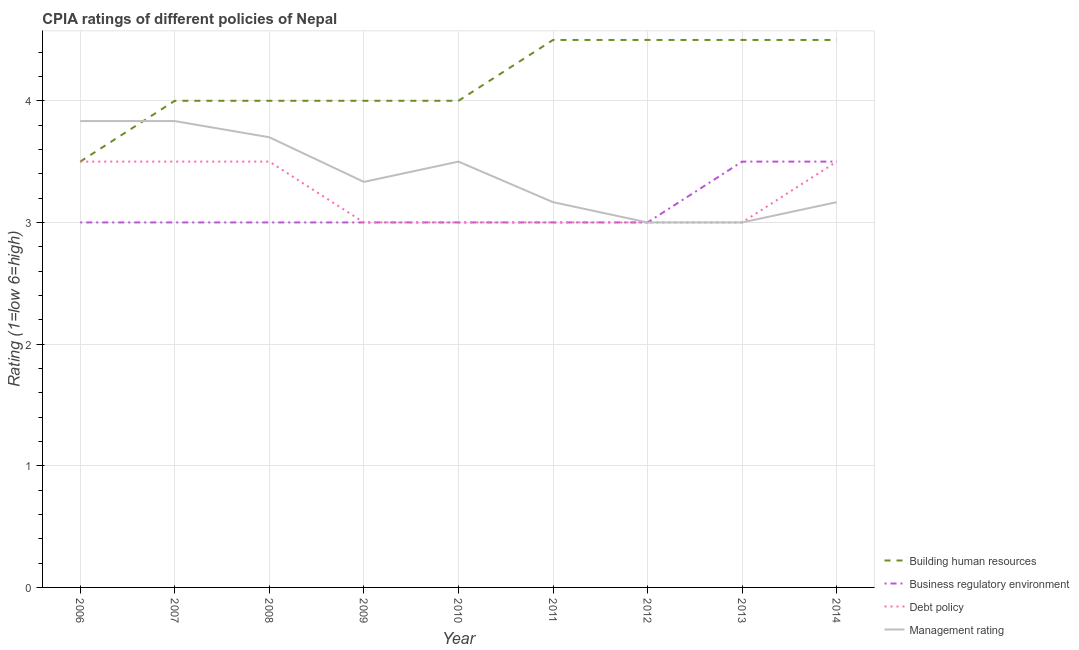How many different coloured lines are there?
Make the answer very short. 4. Across all years, what is the maximum cpia rating of business regulatory environment?
Keep it short and to the point. 3.5. In which year was the cpia rating of management maximum?
Your answer should be compact. 2006. In which year was the cpia rating of business regulatory environment minimum?
Give a very brief answer. 2006. What is the difference between the cpia rating of management in 2008 and that in 2012?
Your answer should be compact. 0.7. What is the difference between the cpia rating of debt policy in 2008 and the cpia rating of business regulatory environment in 2010?
Offer a very short reply. 0.5. What is the average cpia rating of debt policy per year?
Provide a short and direct response. 3.22. In the year 2014, what is the difference between the cpia rating of building human resources and cpia rating of business regulatory environment?
Provide a succinct answer. 1. In how many years, is the cpia rating of building human resources greater than 0.4?
Make the answer very short. 9. Is the cpia rating of management in 2009 less than that in 2013?
Your answer should be compact. No. Is the difference between the cpia rating of building human resources in 2012 and 2014 greater than the difference between the cpia rating of debt policy in 2012 and 2014?
Give a very brief answer. Yes. What is the difference between the highest and the lowest cpia rating of debt policy?
Your answer should be compact. 0.5. Is it the case that in every year, the sum of the cpia rating of business regulatory environment and cpia rating of debt policy is greater than the sum of cpia rating of management and cpia rating of building human resources?
Make the answer very short. No. Is it the case that in every year, the sum of the cpia rating of building human resources and cpia rating of business regulatory environment is greater than the cpia rating of debt policy?
Provide a short and direct response. Yes. Does the cpia rating of debt policy monotonically increase over the years?
Provide a short and direct response. No. Is the cpia rating of building human resources strictly less than the cpia rating of management over the years?
Offer a terse response. No. How many lines are there?
Provide a short and direct response. 4. What is the difference between two consecutive major ticks on the Y-axis?
Provide a short and direct response. 1. What is the title of the graph?
Your answer should be compact. CPIA ratings of different policies of Nepal. What is the label or title of the X-axis?
Ensure brevity in your answer.  Year. What is the label or title of the Y-axis?
Make the answer very short. Rating (1=low 6=high). What is the Rating (1=low 6=high) of Building human resources in 2006?
Your answer should be compact. 3.5. What is the Rating (1=low 6=high) in Business regulatory environment in 2006?
Your response must be concise. 3. What is the Rating (1=low 6=high) in Management rating in 2006?
Your response must be concise. 3.83. What is the Rating (1=low 6=high) in Business regulatory environment in 2007?
Your answer should be compact. 3. What is the Rating (1=low 6=high) in Debt policy in 2007?
Keep it short and to the point. 3.5. What is the Rating (1=low 6=high) of Management rating in 2007?
Ensure brevity in your answer.  3.83. What is the Rating (1=low 6=high) in Building human resources in 2008?
Give a very brief answer. 4. What is the Rating (1=low 6=high) in Business regulatory environment in 2008?
Ensure brevity in your answer.  3. What is the Rating (1=low 6=high) in Management rating in 2008?
Offer a terse response. 3.7. What is the Rating (1=low 6=high) of Building human resources in 2009?
Ensure brevity in your answer.  4. What is the Rating (1=low 6=high) of Business regulatory environment in 2009?
Provide a succinct answer. 3. What is the Rating (1=low 6=high) of Debt policy in 2009?
Offer a very short reply. 3. What is the Rating (1=low 6=high) of Management rating in 2009?
Provide a short and direct response. 3.33. What is the Rating (1=low 6=high) of Building human resources in 2010?
Provide a short and direct response. 4. What is the Rating (1=low 6=high) of Business regulatory environment in 2010?
Your answer should be very brief. 3. What is the Rating (1=low 6=high) of Debt policy in 2010?
Give a very brief answer. 3. What is the Rating (1=low 6=high) of Debt policy in 2011?
Offer a very short reply. 3. What is the Rating (1=low 6=high) of Management rating in 2011?
Your response must be concise. 3.17. What is the Rating (1=low 6=high) in Building human resources in 2013?
Your response must be concise. 4.5. What is the Rating (1=low 6=high) in Management rating in 2014?
Provide a short and direct response. 3.17. Across all years, what is the maximum Rating (1=low 6=high) of Building human resources?
Your answer should be very brief. 4.5. Across all years, what is the maximum Rating (1=low 6=high) of Management rating?
Your response must be concise. 3.83. Across all years, what is the minimum Rating (1=low 6=high) in Business regulatory environment?
Keep it short and to the point. 3. Across all years, what is the minimum Rating (1=low 6=high) of Debt policy?
Offer a terse response. 3. What is the total Rating (1=low 6=high) of Building human resources in the graph?
Provide a succinct answer. 37.5. What is the total Rating (1=low 6=high) of Business regulatory environment in the graph?
Your answer should be very brief. 28. What is the total Rating (1=low 6=high) of Debt policy in the graph?
Provide a succinct answer. 29. What is the total Rating (1=low 6=high) of Management rating in the graph?
Your answer should be very brief. 30.53. What is the difference between the Rating (1=low 6=high) of Business regulatory environment in 2006 and that in 2007?
Your response must be concise. 0. What is the difference between the Rating (1=low 6=high) of Debt policy in 2006 and that in 2007?
Offer a terse response. 0. What is the difference between the Rating (1=low 6=high) in Management rating in 2006 and that in 2007?
Make the answer very short. 0. What is the difference between the Rating (1=low 6=high) of Building human resources in 2006 and that in 2008?
Provide a succinct answer. -0.5. What is the difference between the Rating (1=low 6=high) in Management rating in 2006 and that in 2008?
Your answer should be compact. 0.13. What is the difference between the Rating (1=low 6=high) in Building human resources in 2006 and that in 2009?
Keep it short and to the point. -0.5. What is the difference between the Rating (1=low 6=high) of Debt policy in 2006 and that in 2009?
Make the answer very short. 0.5. What is the difference between the Rating (1=low 6=high) of Management rating in 2006 and that in 2009?
Keep it short and to the point. 0.5. What is the difference between the Rating (1=low 6=high) of Building human resources in 2006 and that in 2010?
Keep it short and to the point. -0.5. What is the difference between the Rating (1=low 6=high) of Management rating in 2006 and that in 2010?
Offer a very short reply. 0.33. What is the difference between the Rating (1=low 6=high) of Business regulatory environment in 2006 and that in 2011?
Provide a succinct answer. 0. What is the difference between the Rating (1=low 6=high) of Debt policy in 2006 and that in 2011?
Ensure brevity in your answer.  0.5. What is the difference between the Rating (1=low 6=high) in Management rating in 2006 and that in 2011?
Ensure brevity in your answer.  0.67. What is the difference between the Rating (1=low 6=high) in Business regulatory environment in 2006 and that in 2012?
Offer a terse response. 0. What is the difference between the Rating (1=low 6=high) of Debt policy in 2006 and that in 2012?
Your response must be concise. 0.5. What is the difference between the Rating (1=low 6=high) in Management rating in 2006 and that in 2012?
Ensure brevity in your answer.  0.83. What is the difference between the Rating (1=low 6=high) in Building human resources in 2006 and that in 2013?
Ensure brevity in your answer.  -1. What is the difference between the Rating (1=low 6=high) of Business regulatory environment in 2006 and that in 2013?
Keep it short and to the point. -0.5. What is the difference between the Rating (1=low 6=high) in Debt policy in 2006 and that in 2013?
Offer a terse response. 0.5. What is the difference between the Rating (1=low 6=high) in Management rating in 2006 and that in 2013?
Your answer should be compact. 0.83. What is the difference between the Rating (1=low 6=high) in Business regulatory environment in 2006 and that in 2014?
Your response must be concise. -0.5. What is the difference between the Rating (1=low 6=high) in Management rating in 2006 and that in 2014?
Ensure brevity in your answer.  0.67. What is the difference between the Rating (1=low 6=high) in Management rating in 2007 and that in 2008?
Your answer should be very brief. 0.13. What is the difference between the Rating (1=low 6=high) in Building human resources in 2007 and that in 2009?
Give a very brief answer. 0. What is the difference between the Rating (1=low 6=high) in Debt policy in 2007 and that in 2009?
Offer a very short reply. 0.5. What is the difference between the Rating (1=low 6=high) of Management rating in 2007 and that in 2009?
Offer a terse response. 0.5. What is the difference between the Rating (1=low 6=high) in Business regulatory environment in 2007 and that in 2010?
Your answer should be compact. 0. What is the difference between the Rating (1=low 6=high) in Debt policy in 2007 and that in 2010?
Give a very brief answer. 0.5. What is the difference between the Rating (1=low 6=high) of Management rating in 2007 and that in 2010?
Offer a very short reply. 0.33. What is the difference between the Rating (1=low 6=high) of Building human resources in 2007 and that in 2011?
Offer a terse response. -0.5. What is the difference between the Rating (1=low 6=high) in Business regulatory environment in 2007 and that in 2011?
Keep it short and to the point. 0. What is the difference between the Rating (1=low 6=high) of Business regulatory environment in 2007 and that in 2012?
Make the answer very short. 0. What is the difference between the Rating (1=low 6=high) in Management rating in 2007 and that in 2012?
Ensure brevity in your answer.  0.83. What is the difference between the Rating (1=low 6=high) of Business regulatory environment in 2007 and that in 2013?
Your answer should be compact. -0.5. What is the difference between the Rating (1=low 6=high) in Building human resources in 2007 and that in 2014?
Provide a succinct answer. -0.5. What is the difference between the Rating (1=low 6=high) of Management rating in 2007 and that in 2014?
Offer a very short reply. 0.67. What is the difference between the Rating (1=low 6=high) of Management rating in 2008 and that in 2009?
Offer a terse response. 0.37. What is the difference between the Rating (1=low 6=high) of Building human resources in 2008 and that in 2010?
Your answer should be very brief. 0. What is the difference between the Rating (1=low 6=high) in Management rating in 2008 and that in 2010?
Your answer should be compact. 0.2. What is the difference between the Rating (1=low 6=high) in Building human resources in 2008 and that in 2011?
Keep it short and to the point. -0.5. What is the difference between the Rating (1=low 6=high) in Debt policy in 2008 and that in 2011?
Keep it short and to the point. 0.5. What is the difference between the Rating (1=low 6=high) of Management rating in 2008 and that in 2011?
Provide a succinct answer. 0.53. What is the difference between the Rating (1=low 6=high) in Business regulatory environment in 2008 and that in 2012?
Provide a short and direct response. 0. What is the difference between the Rating (1=low 6=high) of Management rating in 2008 and that in 2012?
Your answer should be compact. 0.7. What is the difference between the Rating (1=low 6=high) of Building human resources in 2008 and that in 2013?
Make the answer very short. -0.5. What is the difference between the Rating (1=low 6=high) of Management rating in 2008 and that in 2013?
Keep it short and to the point. 0.7. What is the difference between the Rating (1=low 6=high) in Debt policy in 2008 and that in 2014?
Your answer should be compact. 0. What is the difference between the Rating (1=low 6=high) of Management rating in 2008 and that in 2014?
Make the answer very short. 0.53. What is the difference between the Rating (1=low 6=high) of Building human resources in 2009 and that in 2010?
Make the answer very short. 0. What is the difference between the Rating (1=low 6=high) in Business regulatory environment in 2009 and that in 2010?
Your response must be concise. 0. What is the difference between the Rating (1=low 6=high) of Debt policy in 2009 and that in 2010?
Ensure brevity in your answer.  0. What is the difference between the Rating (1=low 6=high) of Management rating in 2009 and that in 2011?
Your response must be concise. 0.17. What is the difference between the Rating (1=low 6=high) in Building human resources in 2009 and that in 2012?
Ensure brevity in your answer.  -0.5. What is the difference between the Rating (1=low 6=high) in Management rating in 2009 and that in 2012?
Offer a very short reply. 0.33. What is the difference between the Rating (1=low 6=high) in Building human resources in 2009 and that in 2013?
Make the answer very short. -0.5. What is the difference between the Rating (1=low 6=high) in Business regulatory environment in 2009 and that in 2013?
Offer a very short reply. -0.5. What is the difference between the Rating (1=low 6=high) of Management rating in 2009 and that in 2013?
Ensure brevity in your answer.  0.33. What is the difference between the Rating (1=low 6=high) of Building human resources in 2009 and that in 2014?
Offer a terse response. -0.5. What is the difference between the Rating (1=low 6=high) in Business regulatory environment in 2009 and that in 2014?
Offer a terse response. -0.5. What is the difference between the Rating (1=low 6=high) of Debt policy in 2009 and that in 2014?
Provide a succinct answer. -0.5. What is the difference between the Rating (1=low 6=high) in Management rating in 2009 and that in 2014?
Offer a terse response. 0.17. What is the difference between the Rating (1=low 6=high) in Building human resources in 2010 and that in 2011?
Keep it short and to the point. -0.5. What is the difference between the Rating (1=low 6=high) of Building human resources in 2010 and that in 2013?
Keep it short and to the point. -0.5. What is the difference between the Rating (1=low 6=high) in Business regulatory environment in 2010 and that in 2013?
Provide a short and direct response. -0.5. What is the difference between the Rating (1=low 6=high) in Management rating in 2010 and that in 2013?
Offer a very short reply. 0.5. What is the difference between the Rating (1=low 6=high) of Building human resources in 2010 and that in 2014?
Provide a short and direct response. -0.5. What is the difference between the Rating (1=low 6=high) in Management rating in 2010 and that in 2014?
Ensure brevity in your answer.  0.33. What is the difference between the Rating (1=low 6=high) in Management rating in 2011 and that in 2012?
Your answer should be compact. 0.17. What is the difference between the Rating (1=low 6=high) of Debt policy in 2011 and that in 2014?
Your response must be concise. -0.5. What is the difference between the Rating (1=low 6=high) of Building human resources in 2012 and that in 2013?
Offer a very short reply. 0. What is the difference between the Rating (1=low 6=high) in Business regulatory environment in 2012 and that in 2013?
Make the answer very short. -0.5. What is the difference between the Rating (1=low 6=high) in Debt policy in 2012 and that in 2013?
Ensure brevity in your answer.  0. What is the difference between the Rating (1=low 6=high) in Management rating in 2012 and that in 2013?
Provide a succinct answer. 0. What is the difference between the Rating (1=low 6=high) in Building human resources in 2012 and that in 2014?
Provide a succinct answer. 0. What is the difference between the Rating (1=low 6=high) of Business regulatory environment in 2012 and that in 2014?
Your answer should be very brief. -0.5. What is the difference between the Rating (1=low 6=high) in Building human resources in 2013 and that in 2014?
Give a very brief answer. 0. What is the difference between the Rating (1=low 6=high) of Business regulatory environment in 2013 and that in 2014?
Give a very brief answer. 0. What is the difference between the Rating (1=low 6=high) of Business regulatory environment in 2006 and the Rating (1=low 6=high) of Management rating in 2007?
Keep it short and to the point. -0.83. What is the difference between the Rating (1=low 6=high) of Building human resources in 2006 and the Rating (1=low 6=high) of Business regulatory environment in 2008?
Offer a terse response. 0.5. What is the difference between the Rating (1=low 6=high) in Building human resources in 2006 and the Rating (1=low 6=high) in Debt policy in 2008?
Ensure brevity in your answer.  0. What is the difference between the Rating (1=low 6=high) in Building human resources in 2006 and the Rating (1=low 6=high) in Management rating in 2008?
Make the answer very short. -0.2. What is the difference between the Rating (1=low 6=high) of Business regulatory environment in 2006 and the Rating (1=low 6=high) of Debt policy in 2008?
Offer a terse response. -0.5. What is the difference between the Rating (1=low 6=high) in Building human resources in 2006 and the Rating (1=low 6=high) in Business regulatory environment in 2009?
Provide a short and direct response. 0.5. What is the difference between the Rating (1=low 6=high) in Business regulatory environment in 2006 and the Rating (1=low 6=high) in Management rating in 2009?
Ensure brevity in your answer.  -0.33. What is the difference between the Rating (1=low 6=high) in Debt policy in 2006 and the Rating (1=low 6=high) in Management rating in 2009?
Provide a short and direct response. 0.17. What is the difference between the Rating (1=low 6=high) of Building human resources in 2006 and the Rating (1=low 6=high) of Business regulatory environment in 2010?
Offer a terse response. 0.5. What is the difference between the Rating (1=low 6=high) in Business regulatory environment in 2006 and the Rating (1=low 6=high) in Management rating in 2010?
Keep it short and to the point. -0.5. What is the difference between the Rating (1=low 6=high) in Debt policy in 2006 and the Rating (1=low 6=high) in Management rating in 2010?
Ensure brevity in your answer.  0. What is the difference between the Rating (1=low 6=high) in Building human resources in 2006 and the Rating (1=low 6=high) in Business regulatory environment in 2011?
Your answer should be very brief. 0.5. What is the difference between the Rating (1=low 6=high) of Building human resources in 2006 and the Rating (1=low 6=high) of Management rating in 2011?
Your answer should be very brief. 0.33. What is the difference between the Rating (1=low 6=high) in Building human resources in 2006 and the Rating (1=low 6=high) in Management rating in 2012?
Your answer should be compact. 0.5. What is the difference between the Rating (1=low 6=high) in Business regulatory environment in 2006 and the Rating (1=low 6=high) in Debt policy in 2012?
Your answer should be compact. 0. What is the difference between the Rating (1=low 6=high) in Building human resources in 2006 and the Rating (1=low 6=high) in Business regulatory environment in 2013?
Offer a very short reply. 0. What is the difference between the Rating (1=low 6=high) in Building human resources in 2006 and the Rating (1=low 6=high) in Management rating in 2013?
Provide a short and direct response. 0.5. What is the difference between the Rating (1=low 6=high) of Business regulatory environment in 2006 and the Rating (1=low 6=high) of Management rating in 2013?
Your answer should be very brief. 0. What is the difference between the Rating (1=low 6=high) in Business regulatory environment in 2006 and the Rating (1=low 6=high) in Management rating in 2014?
Provide a succinct answer. -0.17. What is the difference between the Rating (1=low 6=high) of Building human resources in 2007 and the Rating (1=low 6=high) of Business regulatory environment in 2008?
Offer a very short reply. 1. What is the difference between the Rating (1=low 6=high) in Building human resources in 2007 and the Rating (1=low 6=high) in Debt policy in 2008?
Make the answer very short. 0.5. What is the difference between the Rating (1=low 6=high) in Business regulatory environment in 2007 and the Rating (1=low 6=high) in Management rating in 2008?
Keep it short and to the point. -0.7. What is the difference between the Rating (1=low 6=high) of Building human resources in 2007 and the Rating (1=low 6=high) of Business regulatory environment in 2009?
Keep it short and to the point. 1. What is the difference between the Rating (1=low 6=high) in Business regulatory environment in 2007 and the Rating (1=low 6=high) in Management rating in 2009?
Keep it short and to the point. -0.33. What is the difference between the Rating (1=low 6=high) in Debt policy in 2007 and the Rating (1=low 6=high) in Management rating in 2009?
Keep it short and to the point. 0.17. What is the difference between the Rating (1=low 6=high) in Building human resources in 2007 and the Rating (1=low 6=high) in Business regulatory environment in 2010?
Offer a very short reply. 1. What is the difference between the Rating (1=low 6=high) in Building human resources in 2007 and the Rating (1=low 6=high) in Debt policy in 2010?
Provide a short and direct response. 1. What is the difference between the Rating (1=low 6=high) of Building human resources in 2007 and the Rating (1=low 6=high) of Management rating in 2010?
Offer a very short reply. 0.5. What is the difference between the Rating (1=low 6=high) in Business regulatory environment in 2007 and the Rating (1=low 6=high) in Debt policy in 2010?
Keep it short and to the point. 0. What is the difference between the Rating (1=low 6=high) of Debt policy in 2007 and the Rating (1=low 6=high) of Management rating in 2010?
Provide a short and direct response. 0. What is the difference between the Rating (1=low 6=high) in Building human resources in 2007 and the Rating (1=low 6=high) in Business regulatory environment in 2011?
Your response must be concise. 1. What is the difference between the Rating (1=low 6=high) of Building human resources in 2007 and the Rating (1=low 6=high) of Debt policy in 2011?
Your answer should be very brief. 1. What is the difference between the Rating (1=low 6=high) in Building human resources in 2007 and the Rating (1=low 6=high) in Management rating in 2011?
Ensure brevity in your answer.  0.83. What is the difference between the Rating (1=low 6=high) of Business regulatory environment in 2007 and the Rating (1=low 6=high) of Debt policy in 2011?
Offer a terse response. 0. What is the difference between the Rating (1=low 6=high) of Debt policy in 2007 and the Rating (1=low 6=high) of Management rating in 2011?
Make the answer very short. 0.33. What is the difference between the Rating (1=low 6=high) in Building human resources in 2007 and the Rating (1=low 6=high) in Management rating in 2012?
Keep it short and to the point. 1. What is the difference between the Rating (1=low 6=high) of Business regulatory environment in 2007 and the Rating (1=low 6=high) of Management rating in 2012?
Provide a short and direct response. 0. What is the difference between the Rating (1=low 6=high) in Building human resources in 2007 and the Rating (1=low 6=high) in Business regulatory environment in 2013?
Offer a very short reply. 0.5. What is the difference between the Rating (1=low 6=high) in Business regulatory environment in 2007 and the Rating (1=low 6=high) in Debt policy in 2013?
Ensure brevity in your answer.  0. What is the difference between the Rating (1=low 6=high) in Debt policy in 2007 and the Rating (1=low 6=high) in Management rating in 2013?
Offer a terse response. 0.5. What is the difference between the Rating (1=low 6=high) in Building human resources in 2007 and the Rating (1=low 6=high) in Business regulatory environment in 2014?
Offer a terse response. 0.5. What is the difference between the Rating (1=low 6=high) of Building human resources in 2007 and the Rating (1=low 6=high) of Debt policy in 2014?
Provide a short and direct response. 0.5. What is the difference between the Rating (1=low 6=high) in Building human resources in 2008 and the Rating (1=low 6=high) in Business regulatory environment in 2009?
Ensure brevity in your answer.  1. What is the difference between the Rating (1=low 6=high) in Business regulatory environment in 2008 and the Rating (1=low 6=high) in Debt policy in 2009?
Give a very brief answer. 0. What is the difference between the Rating (1=low 6=high) of Business regulatory environment in 2008 and the Rating (1=low 6=high) of Management rating in 2009?
Give a very brief answer. -0.33. What is the difference between the Rating (1=low 6=high) in Debt policy in 2008 and the Rating (1=low 6=high) in Management rating in 2009?
Make the answer very short. 0.17. What is the difference between the Rating (1=low 6=high) in Business regulatory environment in 2008 and the Rating (1=low 6=high) in Debt policy in 2010?
Provide a short and direct response. 0. What is the difference between the Rating (1=low 6=high) in Business regulatory environment in 2008 and the Rating (1=low 6=high) in Management rating in 2010?
Your answer should be very brief. -0.5. What is the difference between the Rating (1=low 6=high) in Building human resources in 2008 and the Rating (1=low 6=high) in Business regulatory environment in 2011?
Provide a short and direct response. 1. What is the difference between the Rating (1=low 6=high) in Building human resources in 2008 and the Rating (1=low 6=high) in Debt policy in 2011?
Make the answer very short. 1. What is the difference between the Rating (1=low 6=high) in Building human resources in 2008 and the Rating (1=low 6=high) in Management rating in 2011?
Your response must be concise. 0.83. What is the difference between the Rating (1=low 6=high) in Debt policy in 2008 and the Rating (1=low 6=high) in Management rating in 2011?
Your response must be concise. 0.33. What is the difference between the Rating (1=low 6=high) of Business regulatory environment in 2008 and the Rating (1=low 6=high) of Debt policy in 2012?
Make the answer very short. 0. What is the difference between the Rating (1=low 6=high) of Debt policy in 2008 and the Rating (1=low 6=high) of Management rating in 2012?
Your response must be concise. 0.5. What is the difference between the Rating (1=low 6=high) in Building human resources in 2008 and the Rating (1=low 6=high) in Business regulatory environment in 2013?
Your answer should be very brief. 0.5. What is the difference between the Rating (1=low 6=high) of Building human resources in 2008 and the Rating (1=low 6=high) of Debt policy in 2013?
Ensure brevity in your answer.  1. What is the difference between the Rating (1=low 6=high) of Debt policy in 2008 and the Rating (1=low 6=high) of Management rating in 2013?
Your answer should be very brief. 0.5. What is the difference between the Rating (1=low 6=high) in Building human resources in 2008 and the Rating (1=low 6=high) in Management rating in 2014?
Give a very brief answer. 0.83. What is the difference between the Rating (1=low 6=high) in Business regulatory environment in 2008 and the Rating (1=low 6=high) in Debt policy in 2014?
Offer a very short reply. -0.5. What is the difference between the Rating (1=low 6=high) of Business regulatory environment in 2008 and the Rating (1=low 6=high) of Management rating in 2014?
Give a very brief answer. -0.17. What is the difference between the Rating (1=low 6=high) of Debt policy in 2008 and the Rating (1=low 6=high) of Management rating in 2014?
Make the answer very short. 0.33. What is the difference between the Rating (1=low 6=high) of Building human resources in 2009 and the Rating (1=low 6=high) of Debt policy in 2010?
Provide a short and direct response. 1. What is the difference between the Rating (1=low 6=high) in Business regulatory environment in 2009 and the Rating (1=low 6=high) in Management rating in 2010?
Provide a short and direct response. -0.5. What is the difference between the Rating (1=low 6=high) of Debt policy in 2009 and the Rating (1=low 6=high) of Management rating in 2010?
Provide a succinct answer. -0.5. What is the difference between the Rating (1=low 6=high) in Building human resources in 2009 and the Rating (1=low 6=high) in Business regulatory environment in 2011?
Make the answer very short. 1. What is the difference between the Rating (1=low 6=high) in Business regulatory environment in 2009 and the Rating (1=low 6=high) in Debt policy in 2011?
Make the answer very short. 0. What is the difference between the Rating (1=low 6=high) in Building human resources in 2009 and the Rating (1=low 6=high) in Debt policy in 2012?
Your answer should be very brief. 1. What is the difference between the Rating (1=low 6=high) in Building human resources in 2009 and the Rating (1=low 6=high) in Management rating in 2012?
Provide a short and direct response. 1. What is the difference between the Rating (1=low 6=high) of Business regulatory environment in 2009 and the Rating (1=low 6=high) of Management rating in 2012?
Offer a very short reply. 0. What is the difference between the Rating (1=low 6=high) in Debt policy in 2009 and the Rating (1=low 6=high) in Management rating in 2012?
Offer a terse response. 0. What is the difference between the Rating (1=low 6=high) of Building human resources in 2009 and the Rating (1=low 6=high) of Management rating in 2013?
Your response must be concise. 1. What is the difference between the Rating (1=low 6=high) of Business regulatory environment in 2009 and the Rating (1=low 6=high) of Management rating in 2013?
Your answer should be compact. 0. What is the difference between the Rating (1=low 6=high) in Debt policy in 2009 and the Rating (1=low 6=high) in Management rating in 2013?
Ensure brevity in your answer.  0. What is the difference between the Rating (1=low 6=high) of Building human resources in 2009 and the Rating (1=low 6=high) of Debt policy in 2014?
Offer a terse response. 0.5. What is the difference between the Rating (1=low 6=high) of Business regulatory environment in 2009 and the Rating (1=low 6=high) of Debt policy in 2014?
Offer a terse response. -0.5. What is the difference between the Rating (1=low 6=high) in Business regulatory environment in 2009 and the Rating (1=low 6=high) in Management rating in 2014?
Offer a very short reply. -0.17. What is the difference between the Rating (1=low 6=high) of Debt policy in 2009 and the Rating (1=low 6=high) of Management rating in 2014?
Provide a short and direct response. -0.17. What is the difference between the Rating (1=low 6=high) in Building human resources in 2010 and the Rating (1=low 6=high) in Business regulatory environment in 2011?
Ensure brevity in your answer.  1. What is the difference between the Rating (1=low 6=high) in Building human resources in 2010 and the Rating (1=low 6=high) in Debt policy in 2011?
Offer a terse response. 1. What is the difference between the Rating (1=low 6=high) of Business regulatory environment in 2010 and the Rating (1=low 6=high) of Management rating in 2011?
Your response must be concise. -0.17. What is the difference between the Rating (1=low 6=high) of Building human resources in 2010 and the Rating (1=low 6=high) of Business regulatory environment in 2012?
Offer a terse response. 1. What is the difference between the Rating (1=low 6=high) in Business regulatory environment in 2010 and the Rating (1=low 6=high) in Management rating in 2012?
Make the answer very short. 0. What is the difference between the Rating (1=low 6=high) in Debt policy in 2010 and the Rating (1=low 6=high) in Management rating in 2012?
Your response must be concise. 0. What is the difference between the Rating (1=low 6=high) of Building human resources in 2010 and the Rating (1=low 6=high) of Debt policy in 2013?
Ensure brevity in your answer.  1. What is the difference between the Rating (1=low 6=high) of Business regulatory environment in 2010 and the Rating (1=low 6=high) of Debt policy in 2013?
Your response must be concise. 0. What is the difference between the Rating (1=low 6=high) of Debt policy in 2010 and the Rating (1=low 6=high) of Management rating in 2013?
Keep it short and to the point. 0. What is the difference between the Rating (1=low 6=high) of Building human resources in 2010 and the Rating (1=low 6=high) of Business regulatory environment in 2014?
Offer a very short reply. 0.5. What is the difference between the Rating (1=low 6=high) in Business regulatory environment in 2010 and the Rating (1=low 6=high) in Debt policy in 2014?
Provide a short and direct response. -0.5. What is the difference between the Rating (1=low 6=high) of Building human resources in 2011 and the Rating (1=low 6=high) of Debt policy in 2012?
Make the answer very short. 1.5. What is the difference between the Rating (1=low 6=high) in Building human resources in 2011 and the Rating (1=low 6=high) in Management rating in 2012?
Keep it short and to the point. 1.5. What is the difference between the Rating (1=low 6=high) in Business regulatory environment in 2011 and the Rating (1=low 6=high) in Debt policy in 2012?
Your response must be concise. 0. What is the difference between the Rating (1=low 6=high) of Business regulatory environment in 2011 and the Rating (1=low 6=high) of Management rating in 2012?
Give a very brief answer. 0. What is the difference between the Rating (1=low 6=high) of Debt policy in 2011 and the Rating (1=low 6=high) of Management rating in 2012?
Make the answer very short. 0. What is the difference between the Rating (1=low 6=high) in Building human resources in 2011 and the Rating (1=low 6=high) in Debt policy in 2013?
Offer a very short reply. 1.5. What is the difference between the Rating (1=low 6=high) in Business regulatory environment in 2011 and the Rating (1=low 6=high) in Management rating in 2013?
Your answer should be very brief. 0. What is the difference between the Rating (1=low 6=high) in Debt policy in 2011 and the Rating (1=low 6=high) in Management rating in 2013?
Your answer should be compact. 0. What is the difference between the Rating (1=low 6=high) of Building human resources in 2011 and the Rating (1=low 6=high) of Business regulatory environment in 2014?
Your answer should be very brief. 1. What is the difference between the Rating (1=low 6=high) of Building human resources in 2011 and the Rating (1=low 6=high) of Debt policy in 2014?
Your answer should be very brief. 1. What is the difference between the Rating (1=low 6=high) in Building human resources in 2011 and the Rating (1=low 6=high) in Management rating in 2014?
Keep it short and to the point. 1.33. What is the difference between the Rating (1=low 6=high) of Business regulatory environment in 2011 and the Rating (1=low 6=high) of Debt policy in 2014?
Provide a short and direct response. -0.5. What is the difference between the Rating (1=low 6=high) in Business regulatory environment in 2011 and the Rating (1=low 6=high) in Management rating in 2014?
Your answer should be compact. -0.17. What is the difference between the Rating (1=low 6=high) of Building human resources in 2012 and the Rating (1=low 6=high) of Business regulatory environment in 2013?
Give a very brief answer. 1. What is the difference between the Rating (1=low 6=high) of Building human resources in 2012 and the Rating (1=low 6=high) of Debt policy in 2013?
Provide a succinct answer. 1.5. What is the difference between the Rating (1=low 6=high) of Business regulatory environment in 2012 and the Rating (1=low 6=high) of Debt policy in 2013?
Offer a terse response. 0. What is the difference between the Rating (1=low 6=high) in Business regulatory environment in 2012 and the Rating (1=low 6=high) in Management rating in 2013?
Offer a very short reply. 0. What is the difference between the Rating (1=low 6=high) in Building human resources in 2012 and the Rating (1=low 6=high) in Business regulatory environment in 2014?
Provide a succinct answer. 1. What is the difference between the Rating (1=low 6=high) in Building human resources in 2012 and the Rating (1=low 6=high) in Debt policy in 2014?
Offer a terse response. 1. What is the difference between the Rating (1=low 6=high) of Building human resources in 2012 and the Rating (1=low 6=high) of Management rating in 2014?
Provide a succinct answer. 1.33. What is the difference between the Rating (1=low 6=high) of Business regulatory environment in 2012 and the Rating (1=low 6=high) of Management rating in 2014?
Provide a succinct answer. -0.17. What is the difference between the Rating (1=low 6=high) of Building human resources in 2013 and the Rating (1=low 6=high) of Business regulatory environment in 2014?
Make the answer very short. 1. What is the difference between the Rating (1=low 6=high) of Building human resources in 2013 and the Rating (1=low 6=high) of Debt policy in 2014?
Your response must be concise. 1. What is the difference between the Rating (1=low 6=high) in Building human resources in 2013 and the Rating (1=low 6=high) in Management rating in 2014?
Ensure brevity in your answer.  1.33. What is the difference between the Rating (1=low 6=high) of Business regulatory environment in 2013 and the Rating (1=low 6=high) of Debt policy in 2014?
Ensure brevity in your answer.  0. What is the difference between the Rating (1=low 6=high) in Debt policy in 2013 and the Rating (1=low 6=high) in Management rating in 2014?
Offer a very short reply. -0.17. What is the average Rating (1=low 6=high) of Building human resources per year?
Your response must be concise. 4.17. What is the average Rating (1=low 6=high) of Business regulatory environment per year?
Offer a terse response. 3.11. What is the average Rating (1=low 6=high) of Debt policy per year?
Your answer should be very brief. 3.22. What is the average Rating (1=low 6=high) in Management rating per year?
Offer a terse response. 3.39. In the year 2006, what is the difference between the Rating (1=low 6=high) of Building human resources and Rating (1=low 6=high) of Debt policy?
Your response must be concise. 0. In the year 2006, what is the difference between the Rating (1=low 6=high) of Building human resources and Rating (1=low 6=high) of Management rating?
Make the answer very short. -0.33. In the year 2006, what is the difference between the Rating (1=low 6=high) in Business regulatory environment and Rating (1=low 6=high) in Debt policy?
Ensure brevity in your answer.  -0.5. In the year 2006, what is the difference between the Rating (1=low 6=high) of Business regulatory environment and Rating (1=low 6=high) of Management rating?
Provide a short and direct response. -0.83. In the year 2007, what is the difference between the Rating (1=low 6=high) in Building human resources and Rating (1=low 6=high) in Debt policy?
Make the answer very short. 0.5. In the year 2007, what is the difference between the Rating (1=low 6=high) of Building human resources and Rating (1=low 6=high) of Management rating?
Make the answer very short. 0.17. In the year 2007, what is the difference between the Rating (1=low 6=high) of Business regulatory environment and Rating (1=low 6=high) of Debt policy?
Provide a short and direct response. -0.5. In the year 2007, what is the difference between the Rating (1=low 6=high) of Business regulatory environment and Rating (1=low 6=high) of Management rating?
Offer a very short reply. -0.83. In the year 2008, what is the difference between the Rating (1=low 6=high) in Building human resources and Rating (1=low 6=high) in Business regulatory environment?
Your answer should be very brief. 1. In the year 2008, what is the difference between the Rating (1=low 6=high) in Building human resources and Rating (1=low 6=high) in Debt policy?
Ensure brevity in your answer.  0.5. In the year 2008, what is the difference between the Rating (1=low 6=high) of Building human resources and Rating (1=low 6=high) of Management rating?
Provide a short and direct response. 0.3. In the year 2008, what is the difference between the Rating (1=low 6=high) of Business regulatory environment and Rating (1=low 6=high) of Debt policy?
Keep it short and to the point. -0.5. In the year 2008, what is the difference between the Rating (1=low 6=high) in Business regulatory environment and Rating (1=low 6=high) in Management rating?
Give a very brief answer. -0.7. In the year 2008, what is the difference between the Rating (1=low 6=high) of Debt policy and Rating (1=low 6=high) of Management rating?
Make the answer very short. -0.2. In the year 2009, what is the difference between the Rating (1=low 6=high) in Building human resources and Rating (1=low 6=high) in Business regulatory environment?
Give a very brief answer. 1. In the year 2009, what is the difference between the Rating (1=low 6=high) of Building human resources and Rating (1=low 6=high) of Management rating?
Keep it short and to the point. 0.67. In the year 2010, what is the difference between the Rating (1=low 6=high) of Building human resources and Rating (1=low 6=high) of Business regulatory environment?
Your answer should be compact. 1. In the year 2010, what is the difference between the Rating (1=low 6=high) in Building human resources and Rating (1=low 6=high) in Debt policy?
Ensure brevity in your answer.  1. In the year 2010, what is the difference between the Rating (1=low 6=high) in Debt policy and Rating (1=low 6=high) in Management rating?
Your response must be concise. -0.5. In the year 2011, what is the difference between the Rating (1=low 6=high) of Building human resources and Rating (1=low 6=high) of Business regulatory environment?
Ensure brevity in your answer.  1.5. In the year 2011, what is the difference between the Rating (1=low 6=high) of Building human resources and Rating (1=low 6=high) of Debt policy?
Keep it short and to the point. 1.5. In the year 2011, what is the difference between the Rating (1=low 6=high) in Business regulatory environment and Rating (1=low 6=high) in Debt policy?
Ensure brevity in your answer.  0. In the year 2011, what is the difference between the Rating (1=low 6=high) of Debt policy and Rating (1=low 6=high) of Management rating?
Make the answer very short. -0.17. In the year 2012, what is the difference between the Rating (1=low 6=high) in Building human resources and Rating (1=low 6=high) in Debt policy?
Offer a terse response. 1.5. In the year 2012, what is the difference between the Rating (1=low 6=high) in Business regulatory environment and Rating (1=low 6=high) in Debt policy?
Provide a short and direct response. 0. In the year 2012, what is the difference between the Rating (1=low 6=high) in Debt policy and Rating (1=low 6=high) in Management rating?
Provide a succinct answer. 0. In the year 2013, what is the difference between the Rating (1=low 6=high) of Building human resources and Rating (1=low 6=high) of Business regulatory environment?
Provide a short and direct response. 1. In the year 2013, what is the difference between the Rating (1=low 6=high) in Building human resources and Rating (1=low 6=high) in Debt policy?
Offer a very short reply. 1.5. In the year 2013, what is the difference between the Rating (1=low 6=high) of Building human resources and Rating (1=low 6=high) of Management rating?
Your response must be concise. 1.5. In the year 2013, what is the difference between the Rating (1=low 6=high) of Debt policy and Rating (1=low 6=high) of Management rating?
Give a very brief answer. 0. In the year 2014, what is the difference between the Rating (1=low 6=high) of Building human resources and Rating (1=low 6=high) of Management rating?
Provide a succinct answer. 1.33. In the year 2014, what is the difference between the Rating (1=low 6=high) of Business regulatory environment and Rating (1=low 6=high) of Debt policy?
Your answer should be very brief. 0. What is the ratio of the Rating (1=low 6=high) of Business regulatory environment in 2006 to that in 2007?
Your response must be concise. 1. What is the ratio of the Rating (1=low 6=high) in Business regulatory environment in 2006 to that in 2008?
Keep it short and to the point. 1. What is the ratio of the Rating (1=low 6=high) of Debt policy in 2006 to that in 2008?
Make the answer very short. 1. What is the ratio of the Rating (1=low 6=high) in Management rating in 2006 to that in 2008?
Keep it short and to the point. 1.04. What is the ratio of the Rating (1=low 6=high) of Management rating in 2006 to that in 2009?
Offer a terse response. 1.15. What is the ratio of the Rating (1=low 6=high) of Business regulatory environment in 2006 to that in 2010?
Provide a succinct answer. 1. What is the ratio of the Rating (1=low 6=high) of Debt policy in 2006 to that in 2010?
Ensure brevity in your answer.  1.17. What is the ratio of the Rating (1=low 6=high) in Management rating in 2006 to that in 2010?
Provide a succinct answer. 1.1. What is the ratio of the Rating (1=low 6=high) of Building human resources in 2006 to that in 2011?
Provide a short and direct response. 0.78. What is the ratio of the Rating (1=low 6=high) of Management rating in 2006 to that in 2011?
Your answer should be compact. 1.21. What is the ratio of the Rating (1=low 6=high) in Building human resources in 2006 to that in 2012?
Your answer should be very brief. 0.78. What is the ratio of the Rating (1=low 6=high) of Debt policy in 2006 to that in 2012?
Your answer should be very brief. 1.17. What is the ratio of the Rating (1=low 6=high) of Management rating in 2006 to that in 2012?
Your answer should be very brief. 1.28. What is the ratio of the Rating (1=low 6=high) in Business regulatory environment in 2006 to that in 2013?
Your answer should be compact. 0.86. What is the ratio of the Rating (1=low 6=high) in Debt policy in 2006 to that in 2013?
Your response must be concise. 1.17. What is the ratio of the Rating (1=low 6=high) in Management rating in 2006 to that in 2013?
Make the answer very short. 1.28. What is the ratio of the Rating (1=low 6=high) in Business regulatory environment in 2006 to that in 2014?
Your answer should be very brief. 0.86. What is the ratio of the Rating (1=low 6=high) in Management rating in 2006 to that in 2014?
Ensure brevity in your answer.  1.21. What is the ratio of the Rating (1=low 6=high) of Building human resources in 2007 to that in 2008?
Offer a terse response. 1. What is the ratio of the Rating (1=low 6=high) of Management rating in 2007 to that in 2008?
Give a very brief answer. 1.04. What is the ratio of the Rating (1=low 6=high) of Management rating in 2007 to that in 2009?
Provide a succinct answer. 1.15. What is the ratio of the Rating (1=low 6=high) in Management rating in 2007 to that in 2010?
Provide a succinct answer. 1.1. What is the ratio of the Rating (1=low 6=high) of Building human resources in 2007 to that in 2011?
Offer a terse response. 0.89. What is the ratio of the Rating (1=low 6=high) in Management rating in 2007 to that in 2011?
Make the answer very short. 1.21. What is the ratio of the Rating (1=low 6=high) in Business regulatory environment in 2007 to that in 2012?
Offer a terse response. 1. What is the ratio of the Rating (1=low 6=high) in Management rating in 2007 to that in 2012?
Keep it short and to the point. 1.28. What is the ratio of the Rating (1=low 6=high) in Building human resources in 2007 to that in 2013?
Ensure brevity in your answer.  0.89. What is the ratio of the Rating (1=low 6=high) of Business regulatory environment in 2007 to that in 2013?
Your answer should be very brief. 0.86. What is the ratio of the Rating (1=low 6=high) of Debt policy in 2007 to that in 2013?
Ensure brevity in your answer.  1.17. What is the ratio of the Rating (1=low 6=high) of Management rating in 2007 to that in 2013?
Offer a very short reply. 1.28. What is the ratio of the Rating (1=low 6=high) of Management rating in 2007 to that in 2014?
Make the answer very short. 1.21. What is the ratio of the Rating (1=low 6=high) in Building human resources in 2008 to that in 2009?
Make the answer very short. 1. What is the ratio of the Rating (1=low 6=high) of Management rating in 2008 to that in 2009?
Ensure brevity in your answer.  1.11. What is the ratio of the Rating (1=low 6=high) in Building human resources in 2008 to that in 2010?
Give a very brief answer. 1. What is the ratio of the Rating (1=low 6=high) of Management rating in 2008 to that in 2010?
Make the answer very short. 1.06. What is the ratio of the Rating (1=low 6=high) in Management rating in 2008 to that in 2011?
Provide a succinct answer. 1.17. What is the ratio of the Rating (1=low 6=high) of Building human resources in 2008 to that in 2012?
Provide a short and direct response. 0.89. What is the ratio of the Rating (1=low 6=high) in Debt policy in 2008 to that in 2012?
Provide a short and direct response. 1.17. What is the ratio of the Rating (1=low 6=high) of Management rating in 2008 to that in 2012?
Give a very brief answer. 1.23. What is the ratio of the Rating (1=low 6=high) of Building human resources in 2008 to that in 2013?
Provide a succinct answer. 0.89. What is the ratio of the Rating (1=low 6=high) in Business regulatory environment in 2008 to that in 2013?
Your answer should be compact. 0.86. What is the ratio of the Rating (1=low 6=high) in Debt policy in 2008 to that in 2013?
Provide a short and direct response. 1.17. What is the ratio of the Rating (1=low 6=high) of Management rating in 2008 to that in 2013?
Keep it short and to the point. 1.23. What is the ratio of the Rating (1=low 6=high) in Business regulatory environment in 2008 to that in 2014?
Offer a very short reply. 0.86. What is the ratio of the Rating (1=low 6=high) in Management rating in 2008 to that in 2014?
Ensure brevity in your answer.  1.17. What is the ratio of the Rating (1=low 6=high) of Building human resources in 2009 to that in 2010?
Provide a short and direct response. 1. What is the ratio of the Rating (1=low 6=high) of Business regulatory environment in 2009 to that in 2010?
Your answer should be compact. 1. What is the ratio of the Rating (1=low 6=high) of Management rating in 2009 to that in 2010?
Your response must be concise. 0.95. What is the ratio of the Rating (1=low 6=high) of Building human resources in 2009 to that in 2011?
Give a very brief answer. 0.89. What is the ratio of the Rating (1=low 6=high) in Business regulatory environment in 2009 to that in 2011?
Keep it short and to the point. 1. What is the ratio of the Rating (1=low 6=high) of Management rating in 2009 to that in 2011?
Ensure brevity in your answer.  1.05. What is the ratio of the Rating (1=low 6=high) in Building human resources in 2009 to that in 2012?
Offer a terse response. 0.89. What is the ratio of the Rating (1=low 6=high) in Business regulatory environment in 2009 to that in 2012?
Your answer should be very brief. 1. What is the ratio of the Rating (1=low 6=high) in Management rating in 2009 to that in 2012?
Provide a succinct answer. 1.11. What is the ratio of the Rating (1=low 6=high) of Business regulatory environment in 2009 to that in 2013?
Your response must be concise. 0.86. What is the ratio of the Rating (1=low 6=high) in Management rating in 2009 to that in 2013?
Provide a short and direct response. 1.11. What is the ratio of the Rating (1=low 6=high) in Business regulatory environment in 2009 to that in 2014?
Offer a very short reply. 0.86. What is the ratio of the Rating (1=low 6=high) of Management rating in 2009 to that in 2014?
Your answer should be very brief. 1.05. What is the ratio of the Rating (1=low 6=high) in Business regulatory environment in 2010 to that in 2011?
Your answer should be very brief. 1. What is the ratio of the Rating (1=low 6=high) in Debt policy in 2010 to that in 2011?
Offer a terse response. 1. What is the ratio of the Rating (1=low 6=high) in Management rating in 2010 to that in 2011?
Keep it short and to the point. 1.11. What is the ratio of the Rating (1=low 6=high) of Building human resources in 2010 to that in 2012?
Your answer should be very brief. 0.89. What is the ratio of the Rating (1=low 6=high) in Debt policy in 2010 to that in 2012?
Ensure brevity in your answer.  1. What is the ratio of the Rating (1=low 6=high) in Building human resources in 2010 to that in 2013?
Your answer should be compact. 0.89. What is the ratio of the Rating (1=low 6=high) of Business regulatory environment in 2010 to that in 2013?
Ensure brevity in your answer.  0.86. What is the ratio of the Rating (1=low 6=high) in Debt policy in 2010 to that in 2014?
Make the answer very short. 0.86. What is the ratio of the Rating (1=low 6=high) in Management rating in 2010 to that in 2014?
Offer a very short reply. 1.11. What is the ratio of the Rating (1=low 6=high) in Management rating in 2011 to that in 2012?
Provide a short and direct response. 1.06. What is the ratio of the Rating (1=low 6=high) in Building human resources in 2011 to that in 2013?
Your answer should be very brief. 1. What is the ratio of the Rating (1=low 6=high) of Business regulatory environment in 2011 to that in 2013?
Your answer should be compact. 0.86. What is the ratio of the Rating (1=low 6=high) of Management rating in 2011 to that in 2013?
Provide a short and direct response. 1.06. What is the ratio of the Rating (1=low 6=high) in Management rating in 2011 to that in 2014?
Keep it short and to the point. 1. What is the ratio of the Rating (1=low 6=high) of Building human resources in 2012 to that in 2013?
Provide a short and direct response. 1. What is the ratio of the Rating (1=low 6=high) in Business regulatory environment in 2012 to that in 2014?
Keep it short and to the point. 0.86. What is the ratio of the Rating (1=low 6=high) of Debt policy in 2012 to that in 2014?
Make the answer very short. 0.86. What is the ratio of the Rating (1=low 6=high) of Building human resources in 2013 to that in 2014?
Give a very brief answer. 1. What is the ratio of the Rating (1=low 6=high) of Debt policy in 2013 to that in 2014?
Provide a succinct answer. 0.86. What is the ratio of the Rating (1=low 6=high) in Management rating in 2013 to that in 2014?
Offer a terse response. 0.95. What is the difference between the highest and the second highest Rating (1=low 6=high) of Building human resources?
Make the answer very short. 0. What is the difference between the highest and the second highest Rating (1=low 6=high) of Business regulatory environment?
Offer a very short reply. 0. What is the difference between the highest and the lowest Rating (1=low 6=high) in Building human resources?
Offer a very short reply. 1. What is the difference between the highest and the lowest Rating (1=low 6=high) in Business regulatory environment?
Give a very brief answer. 0.5. What is the difference between the highest and the lowest Rating (1=low 6=high) of Debt policy?
Keep it short and to the point. 0.5. What is the difference between the highest and the lowest Rating (1=low 6=high) in Management rating?
Offer a very short reply. 0.83. 